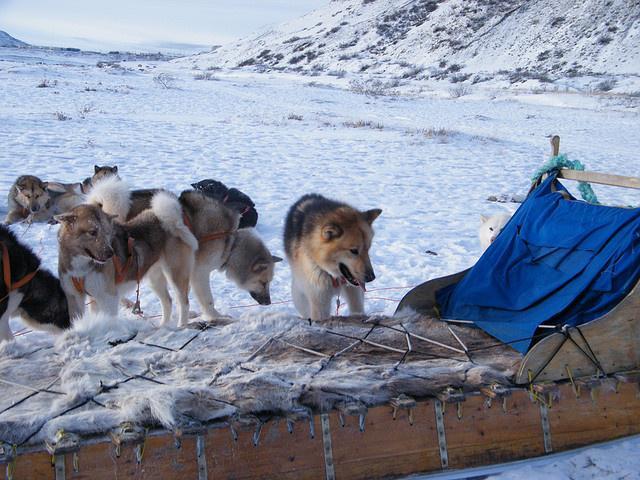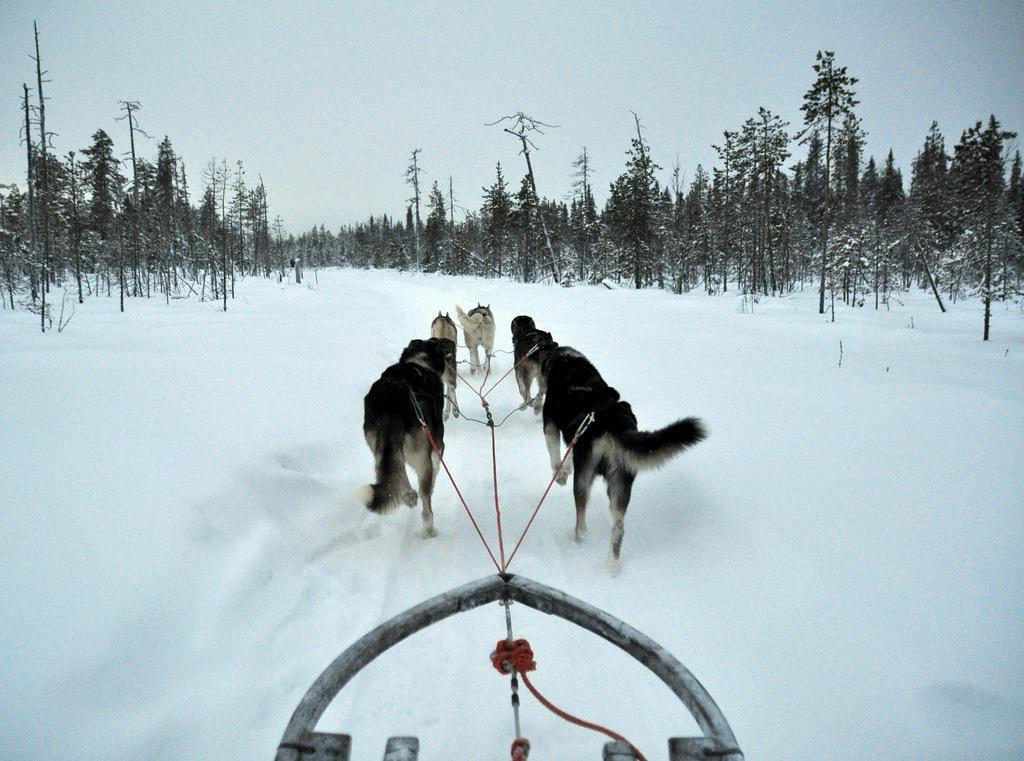The first image is the image on the left, the second image is the image on the right. Given the left and right images, does the statement "In one of the images the photographer's sled is being pulled by dogs." hold true? Answer yes or no. Yes. The first image is the image on the left, the second image is the image on the right. Evaluate the accuracy of this statement regarding the images: "An image shows a team of sled dogs headed toward the camera.". Is it true? Answer yes or no. No. The first image is the image on the left, the second image is the image on the right. Given the left and right images, does the statement "In the left image, the sled dog team is taking a break." hold true? Answer yes or no. Yes. The first image is the image on the left, the second image is the image on the right. Examine the images to the left and right. Is the description "The sled dogs are resting in one of the images." accurate? Answer yes or no. Yes. 